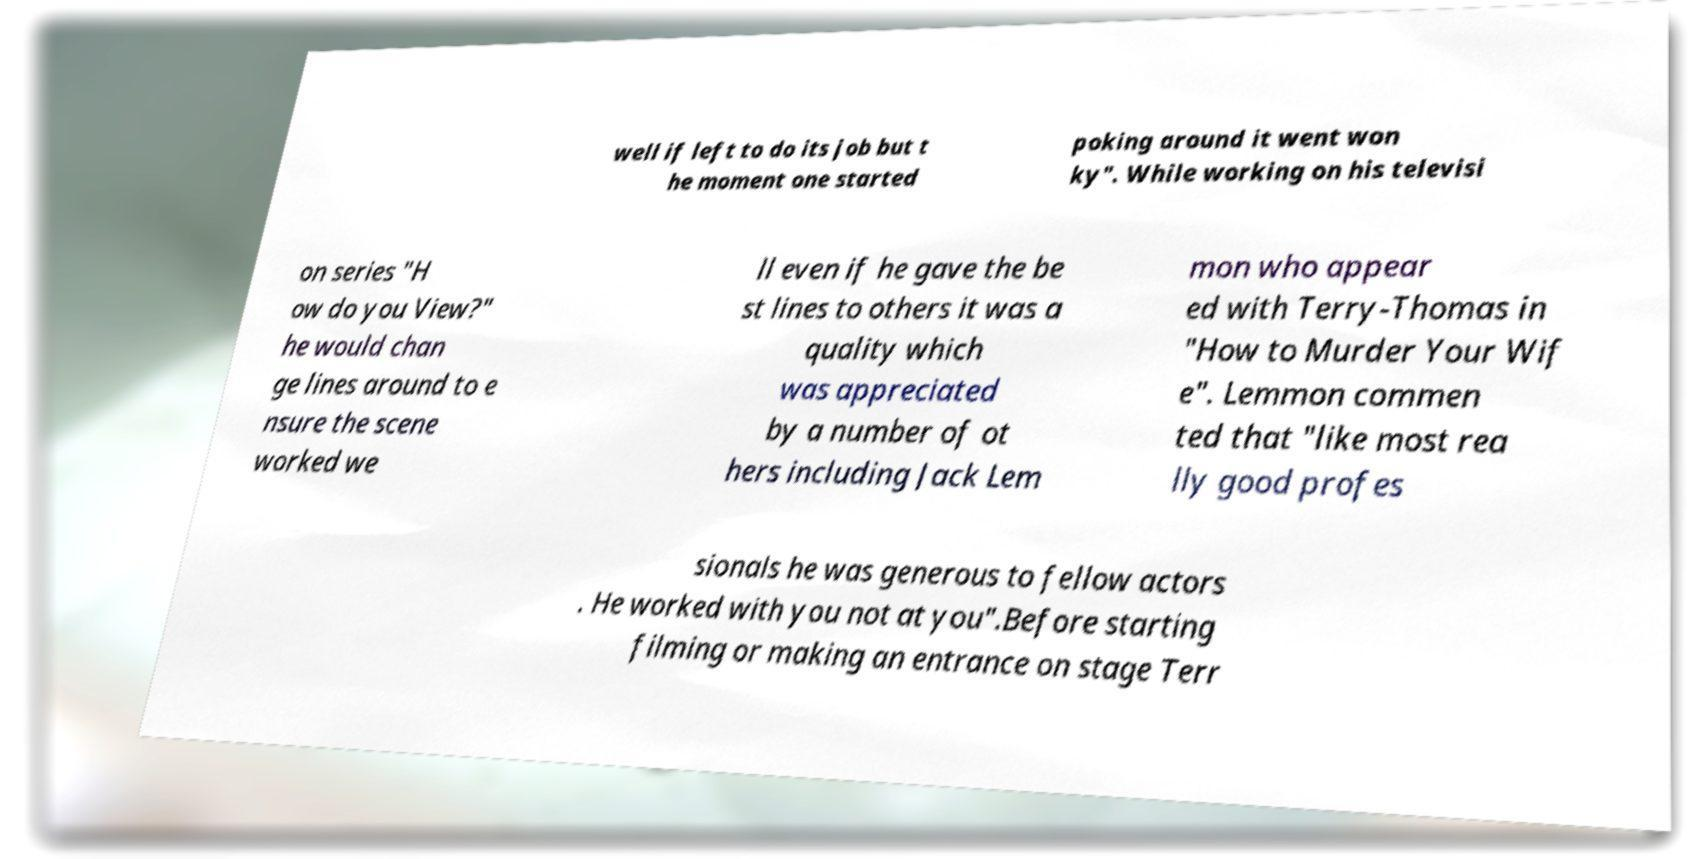Can you read and provide the text displayed in the image?This photo seems to have some interesting text. Can you extract and type it out for me? well if left to do its job but t he moment one started poking around it went won ky". While working on his televisi on series "H ow do you View?" he would chan ge lines around to e nsure the scene worked we ll even if he gave the be st lines to others it was a quality which was appreciated by a number of ot hers including Jack Lem mon who appear ed with Terry-Thomas in "How to Murder Your Wif e". Lemmon commen ted that "like most rea lly good profes sionals he was generous to fellow actors . He worked with you not at you".Before starting filming or making an entrance on stage Terr 